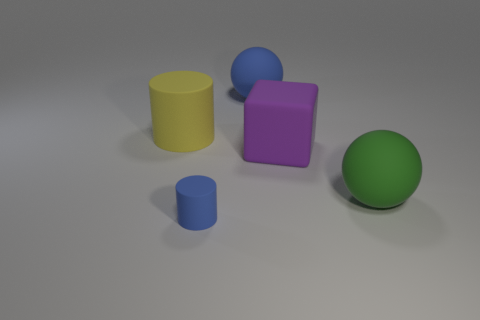Add 2 big purple blocks. How many objects exist? 7 Subtract 1 spheres. How many spheres are left? 1 Subtract all green spheres. How many spheres are left? 1 Subtract all balls. How many objects are left? 3 Subtract all brown balls. Subtract all cyan cubes. How many balls are left? 2 Subtract all blue spheres. How many blue cubes are left? 0 Subtract all large purple blocks. Subtract all large green spheres. How many objects are left? 3 Add 5 yellow things. How many yellow things are left? 6 Add 3 large rubber cylinders. How many large rubber cylinders exist? 4 Subtract 0 yellow balls. How many objects are left? 5 